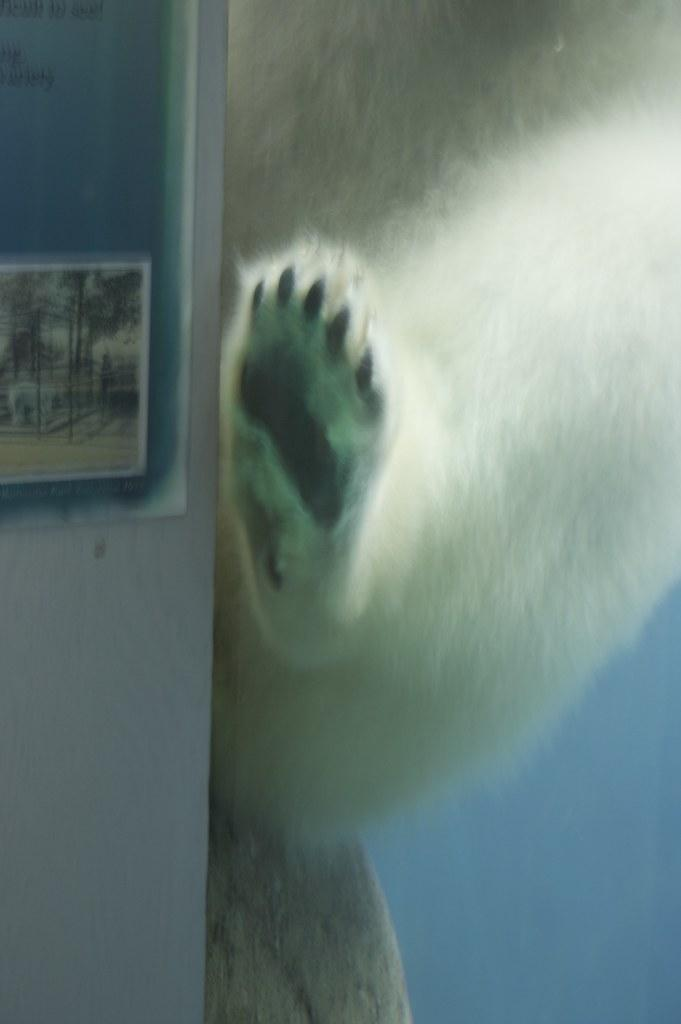What animal is present in the image? There is a bear in the image. What else can be seen on the wall in the image? There is a poster on the wall in the image. How many frogs are jumping around the bear in the image? There are no frogs present in the image; it only features a bear and a poster on the wall. What type of war is depicted in the poster on the wall? There is no war depicted in the poster on the wall, as the poster is not mentioned in the facts provided. 